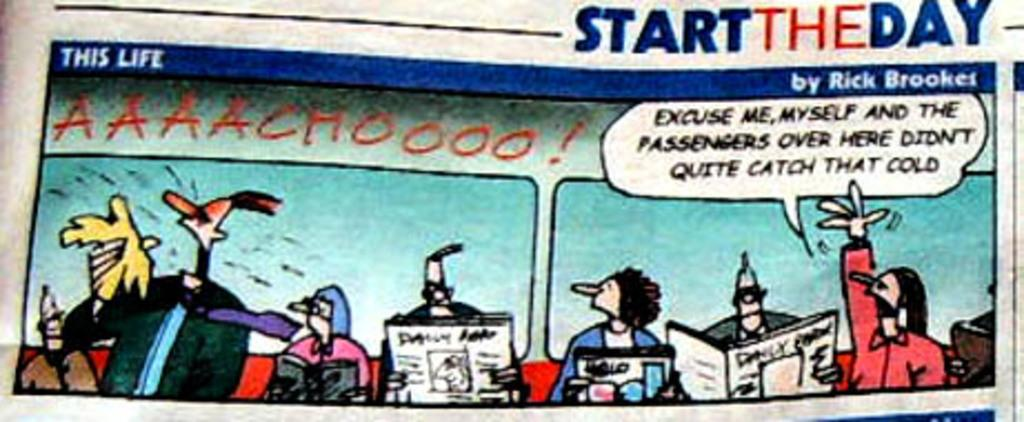<image>
Give a short and clear explanation of the subsequent image. start the day comic ad is on display 